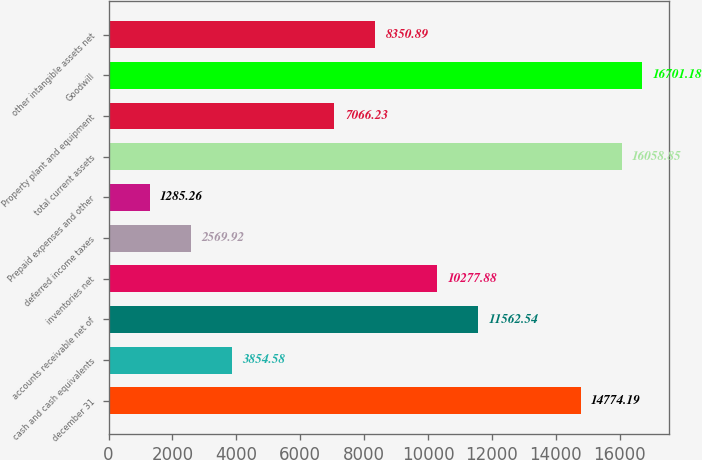Convert chart. <chart><loc_0><loc_0><loc_500><loc_500><bar_chart><fcel>december 31<fcel>cash and cash equivalents<fcel>accounts receivable net of<fcel>inventories net<fcel>deferred income taxes<fcel>Prepaid expenses and other<fcel>total current assets<fcel>Property plant and equipment<fcel>Goodwill<fcel>other intangible assets net<nl><fcel>14774.2<fcel>3854.58<fcel>11562.5<fcel>10277.9<fcel>2569.92<fcel>1285.26<fcel>16058.9<fcel>7066.23<fcel>16701.2<fcel>8350.89<nl></chart> 